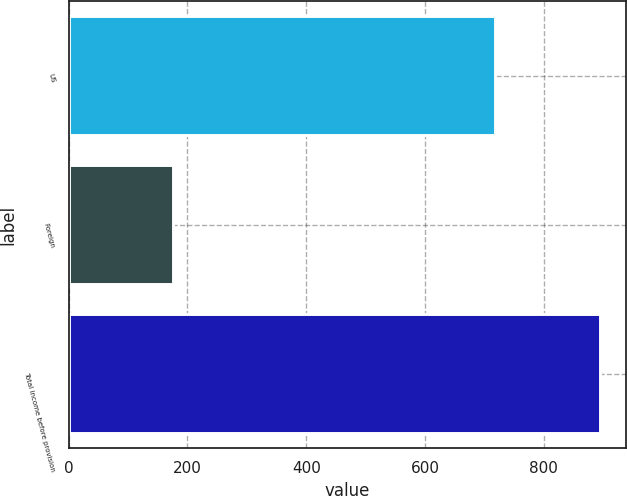Convert chart to OTSL. <chart><loc_0><loc_0><loc_500><loc_500><bar_chart><fcel>US<fcel>Foreign<fcel>Total income before provision<nl><fcel>718.5<fcel>175.4<fcel>893.9<nl></chart> 